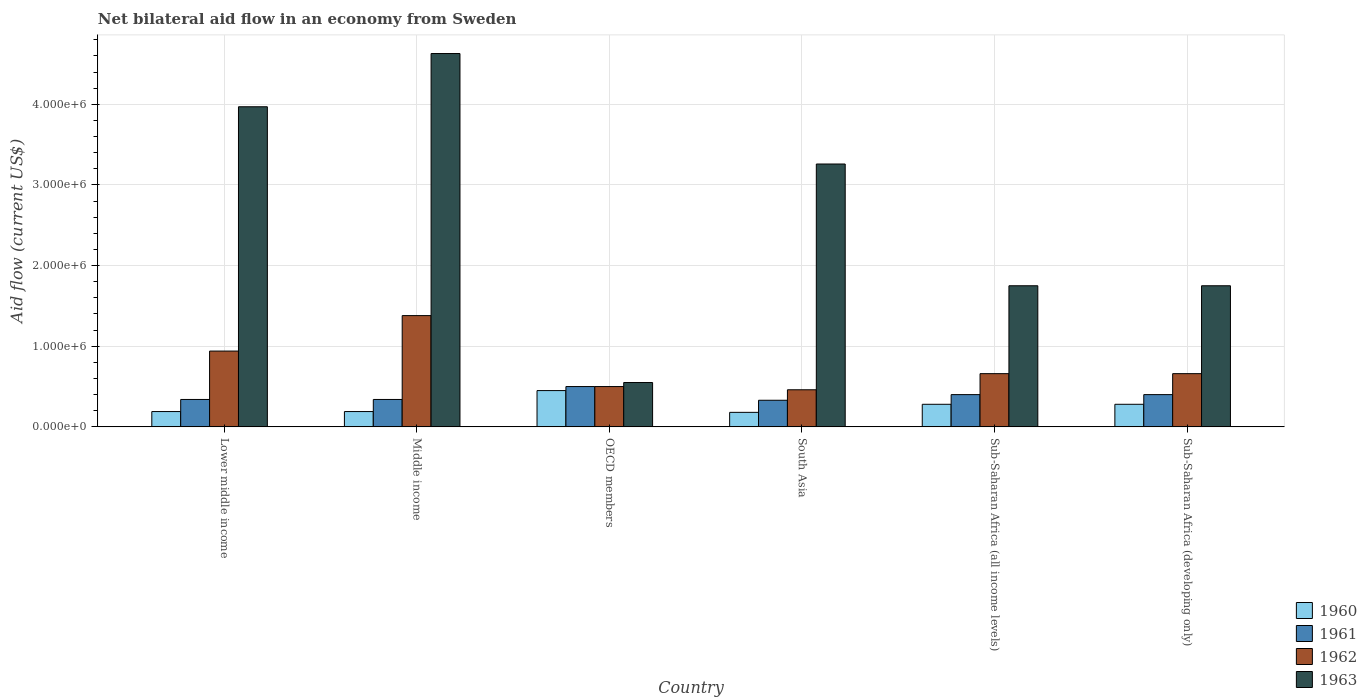How many different coloured bars are there?
Your answer should be very brief. 4. Are the number of bars per tick equal to the number of legend labels?
Provide a short and direct response. Yes. How many bars are there on the 6th tick from the left?
Offer a very short reply. 4. In how many cases, is the number of bars for a given country not equal to the number of legend labels?
Provide a succinct answer. 0. Across all countries, what is the maximum net bilateral aid flow in 1960?
Keep it short and to the point. 4.50e+05. Across all countries, what is the minimum net bilateral aid flow in 1961?
Your response must be concise. 3.30e+05. In which country was the net bilateral aid flow in 1960 maximum?
Provide a short and direct response. OECD members. What is the total net bilateral aid flow in 1962 in the graph?
Keep it short and to the point. 4.60e+06. What is the difference between the net bilateral aid flow in 1963 in South Asia and that in Sub-Saharan Africa (developing only)?
Provide a succinct answer. 1.51e+06. What is the difference between the net bilateral aid flow in 1963 in Sub-Saharan Africa (all income levels) and the net bilateral aid flow in 1962 in South Asia?
Your answer should be very brief. 1.29e+06. What is the average net bilateral aid flow in 1962 per country?
Offer a very short reply. 7.67e+05. What is the difference between the net bilateral aid flow of/in 1962 and net bilateral aid flow of/in 1960 in Lower middle income?
Provide a succinct answer. 7.50e+05. What is the ratio of the net bilateral aid flow in 1961 in South Asia to that in Sub-Saharan Africa (all income levels)?
Your answer should be compact. 0.82. Is the difference between the net bilateral aid flow in 1962 in Lower middle income and Middle income greater than the difference between the net bilateral aid flow in 1960 in Lower middle income and Middle income?
Ensure brevity in your answer.  No. What is the difference between the highest and the second highest net bilateral aid flow in 1962?
Your response must be concise. 7.20e+05. What is the difference between the highest and the lowest net bilateral aid flow in 1963?
Offer a terse response. 4.08e+06. In how many countries, is the net bilateral aid flow in 1960 greater than the average net bilateral aid flow in 1960 taken over all countries?
Ensure brevity in your answer.  3. What does the 2nd bar from the left in South Asia represents?
Provide a short and direct response. 1961. Is it the case that in every country, the sum of the net bilateral aid flow in 1961 and net bilateral aid flow in 1960 is greater than the net bilateral aid flow in 1963?
Ensure brevity in your answer.  No. How many bars are there?
Offer a terse response. 24. Are all the bars in the graph horizontal?
Give a very brief answer. No. What is the difference between two consecutive major ticks on the Y-axis?
Provide a succinct answer. 1.00e+06. How many legend labels are there?
Keep it short and to the point. 4. What is the title of the graph?
Your answer should be very brief. Net bilateral aid flow in an economy from Sweden. Does "1970" appear as one of the legend labels in the graph?
Your answer should be very brief. No. What is the label or title of the Y-axis?
Make the answer very short. Aid flow (current US$). What is the Aid flow (current US$) in 1961 in Lower middle income?
Your answer should be compact. 3.40e+05. What is the Aid flow (current US$) in 1962 in Lower middle income?
Provide a succinct answer. 9.40e+05. What is the Aid flow (current US$) of 1963 in Lower middle income?
Keep it short and to the point. 3.97e+06. What is the Aid flow (current US$) in 1960 in Middle income?
Offer a very short reply. 1.90e+05. What is the Aid flow (current US$) in 1961 in Middle income?
Your response must be concise. 3.40e+05. What is the Aid flow (current US$) of 1962 in Middle income?
Make the answer very short. 1.38e+06. What is the Aid flow (current US$) of 1963 in Middle income?
Give a very brief answer. 4.63e+06. What is the Aid flow (current US$) in 1960 in OECD members?
Provide a short and direct response. 4.50e+05. What is the Aid flow (current US$) in 1962 in OECD members?
Offer a very short reply. 5.00e+05. What is the Aid flow (current US$) of 1963 in OECD members?
Ensure brevity in your answer.  5.50e+05. What is the Aid flow (current US$) in 1962 in South Asia?
Provide a succinct answer. 4.60e+05. What is the Aid flow (current US$) in 1963 in South Asia?
Make the answer very short. 3.26e+06. What is the Aid flow (current US$) of 1960 in Sub-Saharan Africa (all income levels)?
Your answer should be very brief. 2.80e+05. What is the Aid flow (current US$) in 1963 in Sub-Saharan Africa (all income levels)?
Offer a very short reply. 1.75e+06. What is the Aid flow (current US$) in 1960 in Sub-Saharan Africa (developing only)?
Keep it short and to the point. 2.80e+05. What is the Aid flow (current US$) in 1962 in Sub-Saharan Africa (developing only)?
Your answer should be compact. 6.60e+05. What is the Aid flow (current US$) in 1963 in Sub-Saharan Africa (developing only)?
Keep it short and to the point. 1.75e+06. Across all countries, what is the maximum Aid flow (current US$) of 1960?
Keep it short and to the point. 4.50e+05. Across all countries, what is the maximum Aid flow (current US$) in 1961?
Keep it short and to the point. 5.00e+05. Across all countries, what is the maximum Aid flow (current US$) of 1962?
Your answer should be very brief. 1.38e+06. Across all countries, what is the maximum Aid flow (current US$) in 1963?
Provide a succinct answer. 4.63e+06. Across all countries, what is the minimum Aid flow (current US$) in 1961?
Offer a terse response. 3.30e+05. Across all countries, what is the minimum Aid flow (current US$) of 1962?
Offer a terse response. 4.60e+05. What is the total Aid flow (current US$) in 1960 in the graph?
Offer a terse response. 1.57e+06. What is the total Aid flow (current US$) of 1961 in the graph?
Give a very brief answer. 2.31e+06. What is the total Aid flow (current US$) of 1962 in the graph?
Keep it short and to the point. 4.60e+06. What is the total Aid flow (current US$) in 1963 in the graph?
Offer a very short reply. 1.59e+07. What is the difference between the Aid flow (current US$) in 1960 in Lower middle income and that in Middle income?
Your response must be concise. 0. What is the difference between the Aid flow (current US$) in 1962 in Lower middle income and that in Middle income?
Keep it short and to the point. -4.40e+05. What is the difference between the Aid flow (current US$) of 1963 in Lower middle income and that in Middle income?
Offer a terse response. -6.60e+05. What is the difference between the Aid flow (current US$) in 1962 in Lower middle income and that in OECD members?
Offer a very short reply. 4.40e+05. What is the difference between the Aid flow (current US$) of 1963 in Lower middle income and that in OECD members?
Your response must be concise. 3.42e+06. What is the difference between the Aid flow (current US$) in 1961 in Lower middle income and that in South Asia?
Provide a succinct answer. 10000. What is the difference between the Aid flow (current US$) in 1962 in Lower middle income and that in South Asia?
Your answer should be compact. 4.80e+05. What is the difference between the Aid flow (current US$) of 1963 in Lower middle income and that in South Asia?
Give a very brief answer. 7.10e+05. What is the difference between the Aid flow (current US$) in 1962 in Lower middle income and that in Sub-Saharan Africa (all income levels)?
Offer a very short reply. 2.80e+05. What is the difference between the Aid flow (current US$) in 1963 in Lower middle income and that in Sub-Saharan Africa (all income levels)?
Make the answer very short. 2.22e+06. What is the difference between the Aid flow (current US$) of 1960 in Lower middle income and that in Sub-Saharan Africa (developing only)?
Your answer should be compact. -9.00e+04. What is the difference between the Aid flow (current US$) of 1963 in Lower middle income and that in Sub-Saharan Africa (developing only)?
Your answer should be very brief. 2.22e+06. What is the difference between the Aid flow (current US$) of 1960 in Middle income and that in OECD members?
Provide a short and direct response. -2.60e+05. What is the difference between the Aid flow (current US$) in 1962 in Middle income and that in OECD members?
Offer a very short reply. 8.80e+05. What is the difference between the Aid flow (current US$) of 1963 in Middle income and that in OECD members?
Give a very brief answer. 4.08e+06. What is the difference between the Aid flow (current US$) in 1960 in Middle income and that in South Asia?
Ensure brevity in your answer.  10000. What is the difference between the Aid flow (current US$) of 1962 in Middle income and that in South Asia?
Keep it short and to the point. 9.20e+05. What is the difference between the Aid flow (current US$) in 1963 in Middle income and that in South Asia?
Provide a short and direct response. 1.37e+06. What is the difference between the Aid flow (current US$) of 1961 in Middle income and that in Sub-Saharan Africa (all income levels)?
Your response must be concise. -6.00e+04. What is the difference between the Aid flow (current US$) of 1962 in Middle income and that in Sub-Saharan Africa (all income levels)?
Your answer should be very brief. 7.20e+05. What is the difference between the Aid flow (current US$) of 1963 in Middle income and that in Sub-Saharan Africa (all income levels)?
Keep it short and to the point. 2.88e+06. What is the difference between the Aid flow (current US$) of 1961 in Middle income and that in Sub-Saharan Africa (developing only)?
Provide a short and direct response. -6.00e+04. What is the difference between the Aid flow (current US$) in 1962 in Middle income and that in Sub-Saharan Africa (developing only)?
Your answer should be compact. 7.20e+05. What is the difference between the Aid flow (current US$) of 1963 in Middle income and that in Sub-Saharan Africa (developing only)?
Make the answer very short. 2.88e+06. What is the difference between the Aid flow (current US$) of 1963 in OECD members and that in South Asia?
Offer a very short reply. -2.71e+06. What is the difference between the Aid flow (current US$) in 1961 in OECD members and that in Sub-Saharan Africa (all income levels)?
Your answer should be compact. 1.00e+05. What is the difference between the Aid flow (current US$) of 1962 in OECD members and that in Sub-Saharan Africa (all income levels)?
Offer a very short reply. -1.60e+05. What is the difference between the Aid flow (current US$) of 1963 in OECD members and that in Sub-Saharan Africa (all income levels)?
Your response must be concise. -1.20e+06. What is the difference between the Aid flow (current US$) of 1960 in OECD members and that in Sub-Saharan Africa (developing only)?
Offer a very short reply. 1.70e+05. What is the difference between the Aid flow (current US$) in 1963 in OECD members and that in Sub-Saharan Africa (developing only)?
Provide a succinct answer. -1.20e+06. What is the difference between the Aid flow (current US$) of 1961 in South Asia and that in Sub-Saharan Africa (all income levels)?
Make the answer very short. -7.00e+04. What is the difference between the Aid flow (current US$) of 1963 in South Asia and that in Sub-Saharan Africa (all income levels)?
Keep it short and to the point. 1.51e+06. What is the difference between the Aid flow (current US$) of 1960 in South Asia and that in Sub-Saharan Africa (developing only)?
Make the answer very short. -1.00e+05. What is the difference between the Aid flow (current US$) in 1961 in South Asia and that in Sub-Saharan Africa (developing only)?
Make the answer very short. -7.00e+04. What is the difference between the Aid flow (current US$) in 1962 in South Asia and that in Sub-Saharan Africa (developing only)?
Make the answer very short. -2.00e+05. What is the difference between the Aid flow (current US$) of 1963 in South Asia and that in Sub-Saharan Africa (developing only)?
Provide a short and direct response. 1.51e+06. What is the difference between the Aid flow (current US$) of 1960 in Sub-Saharan Africa (all income levels) and that in Sub-Saharan Africa (developing only)?
Keep it short and to the point. 0. What is the difference between the Aid flow (current US$) of 1961 in Sub-Saharan Africa (all income levels) and that in Sub-Saharan Africa (developing only)?
Your response must be concise. 0. What is the difference between the Aid flow (current US$) of 1960 in Lower middle income and the Aid flow (current US$) of 1961 in Middle income?
Your answer should be very brief. -1.50e+05. What is the difference between the Aid flow (current US$) in 1960 in Lower middle income and the Aid flow (current US$) in 1962 in Middle income?
Make the answer very short. -1.19e+06. What is the difference between the Aid flow (current US$) in 1960 in Lower middle income and the Aid flow (current US$) in 1963 in Middle income?
Provide a succinct answer. -4.44e+06. What is the difference between the Aid flow (current US$) of 1961 in Lower middle income and the Aid flow (current US$) of 1962 in Middle income?
Your answer should be very brief. -1.04e+06. What is the difference between the Aid flow (current US$) of 1961 in Lower middle income and the Aid flow (current US$) of 1963 in Middle income?
Your answer should be very brief. -4.29e+06. What is the difference between the Aid flow (current US$) of 1962 in Lower middle income and the Aid flow (current US$) of 1963 in Middle income?
Make the answer very short. -3.69e+06. What is the difference between the Aid flow (current US$) in 1960 in Lower middle income and the Aid flow (current US$) in 1961 in OECD members?
Offer a terse response. -3.10e+05. What is the difference between the Aid flow (current US$) in 1960 in Lower middle income and the Aid flow (current US$) in 1962 in OECD members?
Ensure brevity in your answer.  -3.10e+05. What is the difference between the Aid flow (current US$) in 1960 in Lower middle income and the Aid flow (current US$) in 1963 in OECD members?
Provide a succinct answer. -3.60e+05. What is the difference between the Aid flow (current US$) in 1960 in Lower middle income and the Aid flow (current US$) in 1961 in South Asia?
Give a very brief answer. -1.40e+05. What is the difference between the Aid flow (current US$) in 1960 in Lower middle income and the Aid flow (current US$) in 1962 in South Asia?
Make the answer very short. -2.70e+05. What is the difference between the Aid flow (current US$) of 1960 in Lower middle income and the Aid flow (current US$) of 1963 in South Asia?
Your answer should be very brief. -3.07e+06. What is the difference between the Aid flow (current US$) in 1961 in Lower middle income and the Aid flow (current US$) in 1962 in South Asia?
Keep it short and to the point. -1.20e+05. What is the difference between the Aid flow (current US$) in 1961 in Lower middle income and the Aid flow (current US$) in 1963 in South Asia?
Provide a succinct answer. -2.92e+06. What is the difference between the Aid flow (current US$) in 1962 in Lower middle income and the Aid flow (current US$) in 1963 in South Asia?
Offer a terse response. -2.32e+06. What is the difference between the Aid flow (current US$) in 1960 in Lower middle income and the Aid flow (current US$) in 1962 in Sub-Saharan Africa (all income levels)?
Give a very brief answer. -4.70e+05. What is the difference between the Aid flow (current US$) in 1960 in Lower middle income and the Aid flow (current US$) in 1963 in Sub-Saharan Africa (all income levels)?
Your answer should be very brief. -1.56e+06. What is the difference between the Aid flow (current US$) in 1961 in Lower middle income and the Aid flow (current US$) in 1962 in Sub-Saharan Africa (all income levels)?
Offer a very short reply. -3.20e+05. What is the difference between the Aid flow (current US$) in 1961 in Lower middle income and the Aid flow (current US$) in 1963 in Sub-Saharan Africa (all income levels)?
Provide a succinct answer. -1.41e+06. What is the difference between the Aid flow (current US$) in 1962 in Lower middle income and the Aid flow (current US$) in 1963 in Sub-Saharan Africa (all income levels)?
Offer a very short reply. -8.10e+05. What is the difference between the Aid flow (current US$) of 1960 in Lower middle income and the Aid flow (current US$) of 1962 in Sub-Saharan Africa (developing only)?
Your answer should be compact. -4.70e+05. What is the difference between the Aid flow (current US$) of 1960 in Lower middle income and the Aid flow (current US$) of 1963 in Sub-Saharan Africa (developing only)?
Offer a terse response. -1.56e+06. What is the difference between the Aid flow (current US$) of 1961 in Lower middle income and the Aid flow (current US$) of 1962 in Sub-Saharan Africa (developing only)?
Provide a short and direct response. -3.20e+05. What is the difference between the Aid flow (current US$) of 1961 in Lower middle income and the Aid flow (current US$) of 1963 in Sub-Saharan Africa (developing only)?
Give a very brief answer. -1.41e+06. What is the difference between the Aid flow (current US$) in 1962 in Lower middle income and the Aid flow (current US$) in 1963 in Sub-Saharan Africa (developing only)?
Ensure brevity in your answer.  -8.10e+05. What is the difference between the Aid flow (current US$) of 1960 in Middle income and the Aid flow (current US$) of 1961 in OECD members?
Keep it short and to the point. -3.10e+05. What is the difference between the Aid flow (current US$) in 1960 in Middle income and the Aid flow (current US$) in 1962 in OECD members?
Give a very brief answer. -3.10e+05. What is the difference between the Aid flow (current US$) in 1960 in Middle income and the Aid flow (current US$) in 1963 in OECD members?
Keep it short and to the point. -3.60e+05. What is the difference between the Aid flow (current US$) of 1961 in Middle income and the Aid flow (current US$) of 1963 in OECD members?
Offer a very short reply. -2.10e+05. What is the difference between the Aid flow (current US$) in 1962 in Middle income and the Aid flow (current US$) in 1963 in OECD members?
Make the answer very short. 8.30e+05. What is the difference between the Aid flow (current US$) in 1960 in Middle income and the Aid flow (current US$) in 1962 in South Asia?
Your response must be concise. -2.70e+05. What is the difference between the Aid flow (current US$) in 1960 in Middle income and the Aid flow (current US$) in 1963 in South Asia?
Offer a very short reply. -3.07e+06. What is the difference between the Aid flow (current US$) in 1961 in Middle income and the Aid flow (current US$) in 1963 in South Asia?
Offer a terse response. -2.92e+06. What is the difference between the Aid flow (current US$) in 1962 in Middle income and the Aid flow (current US$) in 1963 in South Asia?
Provide a succinct answer. -1.88e+06. What is the difference between the Aid flow (current US$) of 1960 in Middle income and the Aid flow (current US$) of 1961 in Sub-Saharan Africa (all income levels)?
Your answer should be very brief. -2.10e+05. What is the difference between the Aid flow (current US$) of 1960 in Middle income and the Aid flow (current US$) of 1962 in Sub-Saharan Africa (all income levels)?
Provide a succinct answer. -4.70e+05. What is the difference between the Aid flow (current US$) in 1960 in Middle income and the Aid flow (current US$) in 1963 in Sub-Saharan Africa (all income levels)?
Offer a very short reply. -1.56e+06. What is the difference between the Aid flow (current US$) of 1961 in Middle income and the Aid flow (current US$) of 1962 in Sub-Saharan Africa (all income levels)?
Give a very brief answer. -3.20e+05. What is the difference between the Aid flow (current US$) of 1961 in Middle income and the Aid flow (current US$) of 1963 in Sub-Saharan Africa (all income levels)?
Provide a succinct answer. -1.41e+06. What is the difference between the Aid flow (current US$) in 1962 in Middle income and the Aid flow (current US$) in 1963 in Sub-Saharan Africa (all income levels)?
Your answer should be compact. -3.70e+05. What is the difference between the Aid flow (current US$) in 1960 in Middle income and the Aid flow (current US$) in 1961 in Sub-Saharan Africa (developing only)?
Ensure brevity in your answer.  -2.10e+05. What is the difference between the Aid flow (current US$) of 1960 in Middle income and the Aid flow (current US$) of 1962 in Sub-Saharan Africa (developing only)?
Keep it short and to the point. -4.70e+05. What is the difference between the Aid flow (current US$) of 1960 in Middle income and the Aid flow (current US$) of 1963 in Sub-Saharan Africa (developing only)?
Keep it short and to the point. -1.56e+06. What is the difference between the Aid flow (current US$) of 1961 in Middle income and the Aid flow (current US$) of 1962 in Sub-Saharan Africa (developing only)?
Your response must be concise. -3.20e+05. What is the difference between the Aid flow (current US$) of 1961 in Middle income and the Aid flow (current US$) of 1963 in Sub-Saharan Africa (developing only)?
Provide a short and direct response. -1.41e+06. What is the difference between the Aid flow (current US$) in 1962 in Middle income and the Aid flow (current US$) in 1963 in Sub-Saharan Africa (developing only)?
Your response must be concise. -3.70e+05. What is the difference between the Aid flow (current US$) in 1960 in OECD members and the Aid flow (current US$) in 1963 in South Asia?
Provide a short and direct response. -2.81e+06. What is the difference between the Aid flow (current US$) of 1961 in OECD members and the Aid flow (current US$) of 1963 in South Asia?
Your response must be concise. -2.76e+06. What is the difference between the Aid flow (current US$) in 1962 in OECD members and the Aid flow (current US$) in 1963 in South Asia?
Provide a succinct answer. -2.76e+06. What is the difference between the Aid flow (current US$) of 1960 in OECD members and the Aid flow (current US$) of 1963 in Sub-Saharan Africa (all income levels)?
Your response must be concise. -1.30e+06. What is the difference between the Aid flow (current US$) of 1961 in OECD members and the Aid flow (current US$) of 1963 in Sub-Saharan Africa (all income levels)?
Keep it short and to the point. -1.25e+06. What is the difference between the Aid flow (current US$) in 1962 in OECD members and the Aid flow (current US$) in 1963 in Sub-Saharan Africa (all income levels)?
Your answer should be compact. -1.25e+06. What is the difference between the Aid flow (current US$) of 1960 in OECD members and the Aid flow (current US$) of 1961 in Sub-Saharan Africa (developing only)?
Your response must be concise. 5.00e+04. What is the difference between the Aid flow (current US$) in 1960 in OECD members and the Aid flow (current US$) in 1962 in Sub-Saharan Africa (developing only)?
Ensure brevity in your answer.  -2.10e+05. What is the difference between the Aid flow (current US$) of 1960 in OECD members and the Aid flow (current US$) of 1963 in Sub-Saharan Africa (developing only)?
Provide a succinct answer. -1.30e+06. What is the difference between the Aid flow (current US$) of 1961 in OECD members and the Aid flow (current US$) of 1963 in Sub-Saharan Africa (developing only)?
Offer a very short reply. -1.25e+06. What is the difference between the Aid flow (current US$) in 1962 in OECD members and the Aid flow (current US$) in 1963 in Sub-Saharan Africa (developing only)?
Your answer should be compact. -1.25e+06. What is the difference between the Aid flow (current US$) in 1960 in South Asia and the Aid flow (current US$) in 1961 in Sub-Saharan Africa (all income levels)?
Keep it short and to the point. -2.20e+05. What is the difference between the Aid flow (current US$) in 1960 in South Asia and the Aid flow (current US$) in 1962 in Sub-Saharan Africa (all income levels)?
Provide a short and direct response. -4.80e+05. What is the difference between the Aid flow (current US$) in 1960 in South Asia and the Aid flow (current US$) in 1963 in Sub-Saharan Africa (all income levels)?
Keep it short and to the point. -1.57e+06. What is the difference between the Aid flow (current US$) of 1961 in South Asia and the Aid flow (current US$) of 1962 in Sub-Saharan Africa (all income levels)?
Provide a succinct answer. -3.30e+05. What is the difference between the Aid flow (current US$) in 1961 in South Asia and the Aid flow (current US$) in 1963 in Sub-Saharan Africa (all income levels)?
Provide a short and direct response. -1.42e+06. What is the difference between the Aid flow (current US$) of 1962 in South Asia and the Aid flow (current US$) of 1963 in Sub-Saharan Africa (all income levels)?
Offer a very short reply. -1.29e+06. What is the difference between the Aid flow (current US$) of 1960 in South Asia and the Aid flow (current US$) of 1962 in Sub-Saharan Africa (developing only)?
Provide a succinct answer. -4.80e+05. What is the difference between the Aid flow (current US$) in 1960 in South Asia and the Aid flow (current US$) in 1963 in Sub-Saharan Africa (developing only)?
Your answer should be very brief. -1.57e+06. What is the difference between the Aid flow (current US$) in 1961 in South Asia and the Aid flow (current US$) in 1962 in Sub-Saharan Africa (developing only)?
Keep it short and to the point. -3.30e+05. What is the difference between the Aid flow (current US$) of 1961 in South Asia and the Aid flow (current US$) of 1963 in Sub-Saharan Africa (developing only)?
Keep it short and to the point. -1.42e+06. What is the difference between the Aid flow (current US$) in 1962 in South Asia and the Aid flow (current US$) in 1963 in Sub-Saharan Africa (developing only)?
Provide a short and direct response. -1.29e+06. What is the difference between the Aid flow (current US$) of 1960 in Sub-Saharan Africa (all income levels) and the Aid flow (current US$) of 1962 in Sub-Saharan Africa (developing only)?
Keep it short and to the point. -3.80e+05. What is the difference between the Aid flow (current US$) of 1960 in Sub-Saharan Africa (all income levels) and the Aid flow (current US$) of 1963 in Sub-Saharan Africa (developing only)?
Offer a terse response. -1.47e+06. What is the difference between the Aid flow (current US$) of 1961 in Sub-Saharan Africa (all income levels) and the Aid flow (current US$) of 1962 in Sub-Saharan Africa (developing only)?
Provide a short and direct response. -2.60e+05. What is the difference between the Aid flow (current US$) in 1961 in Sub-Saharan Africa (all income levels) and the Aid flow (current US$) in 1963 in Sub-Saharan Africa (developing only)?
Your answer should be compact. -1.35e+06. What is the difference between the Aid flow (current US$) of 1962 in Sub-Saharan Africa (all income levels) and the Aid flow (current US$) of 1963 in Sub-Saharan Africa (developing only)?
Ensure brevity in your answer.  -1.09e+06. What is the average Aid flow (current US$) in 1960 per country?
Provide a short and direct response. 2.62e+05. What is the average Aid flow (current US$) of 1961 per country?
Provide a succinct answer. 3.85e+05. What is the average Aid flow (current US$) of 1962 per country?
Keep it short and to the point. 7.67e+05. What is the average Aid flow (current US$) of 1963 per country?
Offer a terse response. 2.65e+06. What is the difference between the Aid flow (current US$) of 1960 and Aid flow (current US$) of 1962 in Lower middle income?
Offer a terse response. -7.50e+05. What is the difference between the Aid flow (current US$) of 1960 and Aid flow (current US$) of 1963 in Lower middle income?
Offer a very short reply. -3.78e+06. What is the difference between the Aid flow (current US$) in 1961 and Aid flow (current US$) in 1962 in Lower middle income?
Provide a succinct answer. -6.00e+05. What is the difference between the Aid flow (current US$) in 1961 and Aid flow (current US$) in 1963 in Lower middle income?
Keep it short and to the point. -3.63e+06. What is the difference between the Aid flow (current US$) of 1962 and Aid flow (current US$) of 1963 in Lower middle income?
Your answer should be compact. -3.03e+06. What is the difference between the Aid flow (current US$) of 1960 and Aid flow (current US$) of 1961 in Middle income?
Ensure brevity in your answer.  -1.50e+05. What is the difference between the Aid flow (current US$) of 1960 and Aid flow (current US$) of 1962 in Middle income?
Make the answer very short. -1.19e+06. What is the difference between the Aid flow (current US$) in 1960 and Aid flow (current US$) in 1963 in Middle income?
Your answer should be very brief. -4.44e+06. What is the difference between the Aid flow (current US$) of 1961 and Aid flow (current US$) of 1962 in Middle income?
Offer a very short reply. -1.04e+06. What is the difference between the Aid flow (current US$) in 1961 and Aid flow (current US$) in 1963 in Middle income?
Your response must be concise. -4.29e+06. What is the difference between the Aid flow (current US$) in 1962 and Aid flow (current US$) in 1963 in Middle income?
Offer a terse response. -3.25e+06. What is the difference between the Aid flow (current US$) of 1960 and Aid flow (current US$) of 1962 in OECD members?
Ensure brevity in your answer.  -5.00e+04. What is the difference between the Aid flow (current US$) in 1961 and Aid flow (current US$) in 1963 in OECD members?
Ensure brevity in your answer.  -5.00e+04. What is the difference between the Aid flow (current US$) in 1960 and Aid flow (current US$) in 1961 in South Asia?
Your response must be concise. -1.50e+05. What is the difference between the Aid flow (current US$) in 1960 and Aid flow (current US$) in 1962 in South Asia?
Provide a succinct answer. -2.80e+05. What is the difference between the Aid flow (current US$) of 1960 and Aid flow (current US$) of 1963 in South Asia?
Offer a very short reply. -3.08e+06. What is the difference between the Aid flow (current US$) of 1961 and Aid flow (current US$) of 1962 in South Asia?
Ensure brevity in your answer.  -1.30e+05. What is the difference between the Aid flow (current US$) of 1961 and Aid flow (current US$) of 1963 in South Asia?
Provide a succinct answer. -2.93e+06. What is the difference between the Aid flow (current US$) of 1962 and Aid flow (current US$) of 1963 in South Asia?
Make the answer very short. -2.80e+06. What is the difference between the Aid flow (current US$) of 1960 and Aid flow (current US$) of 1962 in Sub-Saharan Africa (all income levels)?
Make the answer very short. -3.80e+05. What is the difference between the Aid flow (current US$) of 1960 and Aid flow (current US$) of 1963 in Sub-Saharan Africa (all income levels)?
Give a very brief answer. -1.47e+06. What is the difference between the Aid flow (current US$) of 1961 and Aid flow (current US$) of 1962 in Sub-Saharan Africa (all income levels)?
Keep it short and to the point. -2.60e+05. What is the difference between the Aid flow (current US$) of 1961 and Aid flow (current US$) of 1963 in Sub-Saharan Africa (all income levels)?
Ensure brevity in your answer.  -1.35e+06. What is the difference between the Aid flow (current US$) in 1962 and Aid flow (current US$) in 1963 in Sub-Saharan Africa (all income levels)?
Offer a terse response. -1.09e+06. What is the difference between the Aid flow (current US$) of 1960 and Aid flow (current US$) of 1962 in Sub-Saharan Africa (developing only)?
Ensure brevity in your answer.  -3.80e+05. What is the difference between the Aid flow (current US$) in 1960 and Aid flow (current US$) in 1963 in Sub-Saharan Africa (developing only)?
Your response must be concise. -1.47e+06. What is the difference between the Aid flow (current US$) of 1961 and Aid flow (current US$) of 1962 in Sub-Saharan Africa (developing only)?
Make the answer very short. -2.60e+05. What is the difference between the Aid flow (current US$) in 1961 and Aid flow (current US$) in 1963 in Sub-Saharan Africa (developing only)?
Make the answer very short. -1.35e+06. What is the difference between the Aid flow (current US$) in 1962 and Aid flow (current US$) in 1963 in Sub-Saharan Africa (developing only)?
Keep it short and to the point. -1.09e+06. What is the ratio of the Aid flow (current US$) of 1960 in Lower middle income to that in Middle income?
Provide a succinct answer. 1. What is the ratio of the Aid flow (current US$) in 1962 in Lower middle income to that in Middle income?
Provide a succinct answer. 0.68. What is the ratio of the Aid flow (current US$) in 1963 in Lower middle income to that in Middle income?
Give a very brief answer. 0.86. What is the ratio of the Aid flow (current US$) of 1960 in Lower middle income to that in OECD members?
Provide a short and direct response. 0.42. What is the ratio of the Aid flow (current US$) of 1961 in Lower middle income to that in OECD members?
Your answer should be compact. 0.68. What is the ratio of the Aid flow (current US$) in 1962 in Lower middle income to that in OECD members?
Offer a terse response. 1.88. What is the ratio of the Aid flow (current US$) in 1963 in Lower middle income to that in OECD members?
Keep it short and to the point. 7.22. What is the ratio of the Aid flow (current US$) in 1960 in Lower middle income to that in South Asia?
Offer a terse response. 1.06. What is the ratio of the Aid flow (current US$) of 1961 in Lower middle income to that in South Asia?
Your response must be concise. 1.03. What is the ratio of the Aid flow (current US$) in 1962 in Lower middle income to that in South Asia?
Keep it short and to the point. 2.04. What is the ratio of the Aid flow (current US$) in 1963 in Lower middle income to that in South Asia?
Offer a terse response. 1.22. What is the ratio of the Aid flow (current US$) in 1960 in Lower middle income to that in Sub-Saharan Africa (all income levels)?
Your response must be concise. 0.68. What is the ratio of the Aid flow (current US$) in 1962 in Lower middle income to that in Sub-Saharan Africa (all income levels)?
Provide a succinct answer. 1.42. What is the ratio of the Aid flow (current US$) of 1963 in Lower middle income to that in Sub-Saharan Africa (all income levels)?
Give a very brief answer. 2.27. What is the ratio of the Aid flow (current US$) of 1960 in Lower middle income to that in Sub-Saharan Africa (developing only)?
Your answer should be compact. 0.68. What is the ratio of the Aid flow (current US$) of 1962 in Lower middle income to that in Sub-Saharan Africa (developing only)?
Make the answer very short. 1.42. What is the ratio of the Aid flow (current US$) of 1963 in Lower middle income to that in Sub-Saharan Africa (developing only)?
Make the answer very short. 2.27. What is the ratio of the Aid flow (current US$) in 1960 in Middle income to that in OECD members?
Provide a succinct answer. 0.42. What is the ratio of the Aid flow (current US$) in 1961 in Middle income to that in OECD members?
Your response must be concise. 0.68. What is the ratio of the Aid flow (current US$) of 1962 in Middle income to that in OECD members?
Provide a short and direct response. 2.76. What is the ratio of the Aid flow (current US$) of 1963 in Middle income to that in OECD members?
Ensure brevity in your answer.  8.42. What is the ratio of the Aid flow (current US$) in 1960 in Middle income to that in South Asia?
Provide a short and direct response. 1.06. What is the ratio of the Aid flow (current US$) in 1961 in Middle income to that in South Asia?
Keep it short and to the point. 1.03. What is the ratio of the Aid flow (current US$) in 1962 in Middle income to that in South Asia?
Keep it short and to the point. 3. What is the ratio of the Aid flow (current US$) of 1963 in Middle income to that in South Asia?
Provide a succinct answer. 1.42. What is the ratio of the Aid flow (current US$) of 1960 in Middle income to that in Sub-Saharan Africa (all income levels)?
Your response must be concise. 0.68. What is the ratio of the Aid flow (current US$) in 1962 in Middle income to that in Sub-Saharan Africa (all income levels)?
Provide a short and direct response. 2.09. What is the ratio of the Aid flow (current US$) in 1963 in Middle income to that in Sub-Saharan Africa (all income levels)?
Offer a terse response. 2.65. What is the ratio of the Aid flow (current US$) in 1960 in Middle income to that in Sub-Saharan Africa (developing only)?
Give a very brief answer. 0.68. What is the ratio of the Aid flow (current US$) in 1961 in Middle income to that in Sub-Saharan Africa (developing only)?
Give a very brief answer. 0.85. What is the ratio of the Aid flow (current US$) of 1962 in Middle income to that in Sub-Saharan Africa (developing only)?
Offer a very short reply. 2.09. What is the ratio of the Aid flow (current US$) of 1963 in Middle income to that in Sub-Saharan Africa (developing only)?
Provide a succinct answer. 2.65. What is the ratio of the Aid flow (current US$) in 1961 in OECD members to that in South Asia?
Keep it short and to the point. 1.52. What is the ratio of the Aid flow (current US$) of 1962 in OECD members to that in South Asia?
Ensure brevity in your answer.  1.09. What is the ratio of the Aid flow (current US$) in 1963 in OECD members to that in South Asia?
Provide a succinct answer. 0.17. What is the ratio of the Aid flow (current US$) of 1960 in OECD members to that in Sub-Saharan Africa (all income levels)?
Your answer should be compact. 1.61. What is the ratio of the Aid flow (current US$) in 1961 in OECD members to that in Sub-Saharan Africa (all income levels)?
Provide a short and direct response. 1.25. What is the ratio of the Aid flow (current US$) in 1962 in OECD members to that in Sub-Saharan Africa (all income levels)?
Keep it short and to the point. 0.76. What is the ratio of the Aid flow (current US$) in 1963 in OECD members to that in Sub-Saharan Africa (all income levels)?
Your response must be concise. 0.31. What is the ratio of the Aid flow (current US$) in 1960 in OECD members to that in Sub-Saharan Africa (developing only)?
Your answer should be compact. 1.61. What is the ratio of the Aid flow (current US$) of 1961 in OECD members to that in Sub-Saharan Africa (developing only)?
Your response must be concise. 1.25. What is the ratio of the Aid flow (current US$) in 1962 in OECD members to that in Sub-Saharan Africa (developing only)?
Keep it short and to the point. 0.76. What is the ratio of the Aid flow (current US$) in 1963 in OECD members to that in Sub-Saharan Africa (developing only)?
Give a very brief answer. 0.31. What is the ratio of the Aid flow (current US$) in 1960 in South Asia to that in Sub-Saharan Africa (all income levels)?
Your answer should be very brief. 0.64. What is the ratio of the Aid flow (current US$) of 1961 in South Asia to that in Sub-Saharan Africa (all income levels)?
Your response must be concise. 0.82. What is the ratio of the Aid flow (current US$) in 1962 in South Asia to that in Sub-Saharan Africa (all income levels)?
Your response must be concise. 0.7. What is the ratio of the Aid flow (current US$) in 1963 in South Asia to that in Sub-Saharan Africa (all income levels)?
Provide a short and direct response. 1.86. What is the ratio of the Aid flow (current US$) in 1960 in South Asia to that in Sub-Saharan Africa (developing only)?
Keep it short and to the point. 0.64. What is the ratio of the Aid flow (current US$) of 1961 in South Asia to that in Sub-Saharan Africa (developing only)?
Keep it short and to the point. 0.82. What is the ratio of the Aid flow (current US$) of 1962 in South Asia to that in Sub-Saharan Africa (developing only)?
Provide a short and direct response. 0.7. What is the ratio of the Aid flow (current US$) of 1963 in South Asia to that in Sub-Saharan Africa (developing only)?
Ensure brevity in your answer.  1.86. What is the ratio of the Aid flow (current US$) in 1960 in Sub-Saharan Africa (all income levels) to that in Sub-Saharan Africa (developing only)?
Provide a succinct answer. 1. What is the ratio of the Aid flow (current US$) in 1961 in Sub-Saharan Africa (all income levels) to that in Sub-Saharan Africa (developing only)?
Your answer should be very brief. 1. What is the ratio of the Aid flow (current US$) of 1962 in Sub-Saharan Africa (all income levels) to that in Sub-Saharan Africa (developing only)?
Your answer should be very brief. 1. What is the difference between the highest and the second highest Aid flow (current US$) of 1960?
Offer a very short reply. 1.70e+05. What is the difference between the highest and the second highest Aid flow (current US$) in 1962?
Keep it short and to the point. 4.40e+05. What is the difference between the highest and the second highest Aid flow (current US$) of 1963?
Make the answer very short. 6.60e+05. What is the difference between the highest and the lowest Aid flow (current US$) of 1960?
Your answer should be compact. 2.70e+05. What is the difference between the highest and the lowest Aid flow (current US$) of 1961?
Provide a succinct answer. 1.70e+05. What is the difference between the highest and the lowest Aid flow (current US$) of 1962?
Offer a very short reply. 9.20e+05. What is the difference between the highest and the lowest Aid flow (current US$) in 1963?
Offer a very short reply. 4.08e+06. 